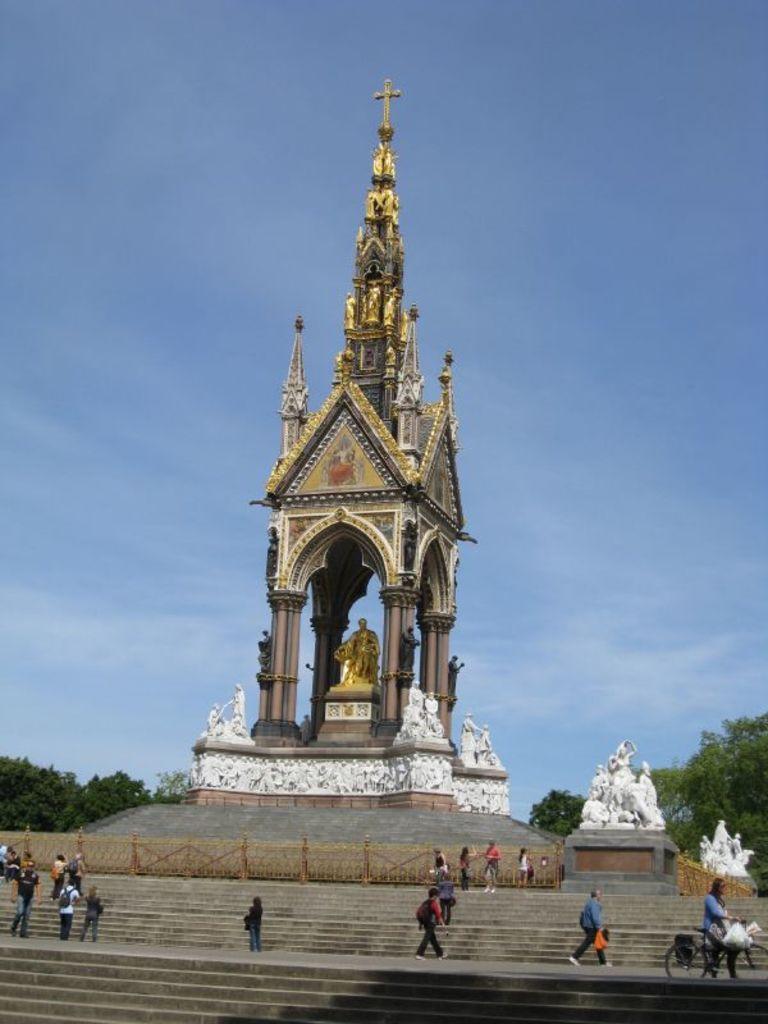Describe this image in one or two sentences. In this image we can see many people. There is a church in the image. There are staircases in the image. We can see the sky in the image. There are few trees in the image. There is a fence in the image. 